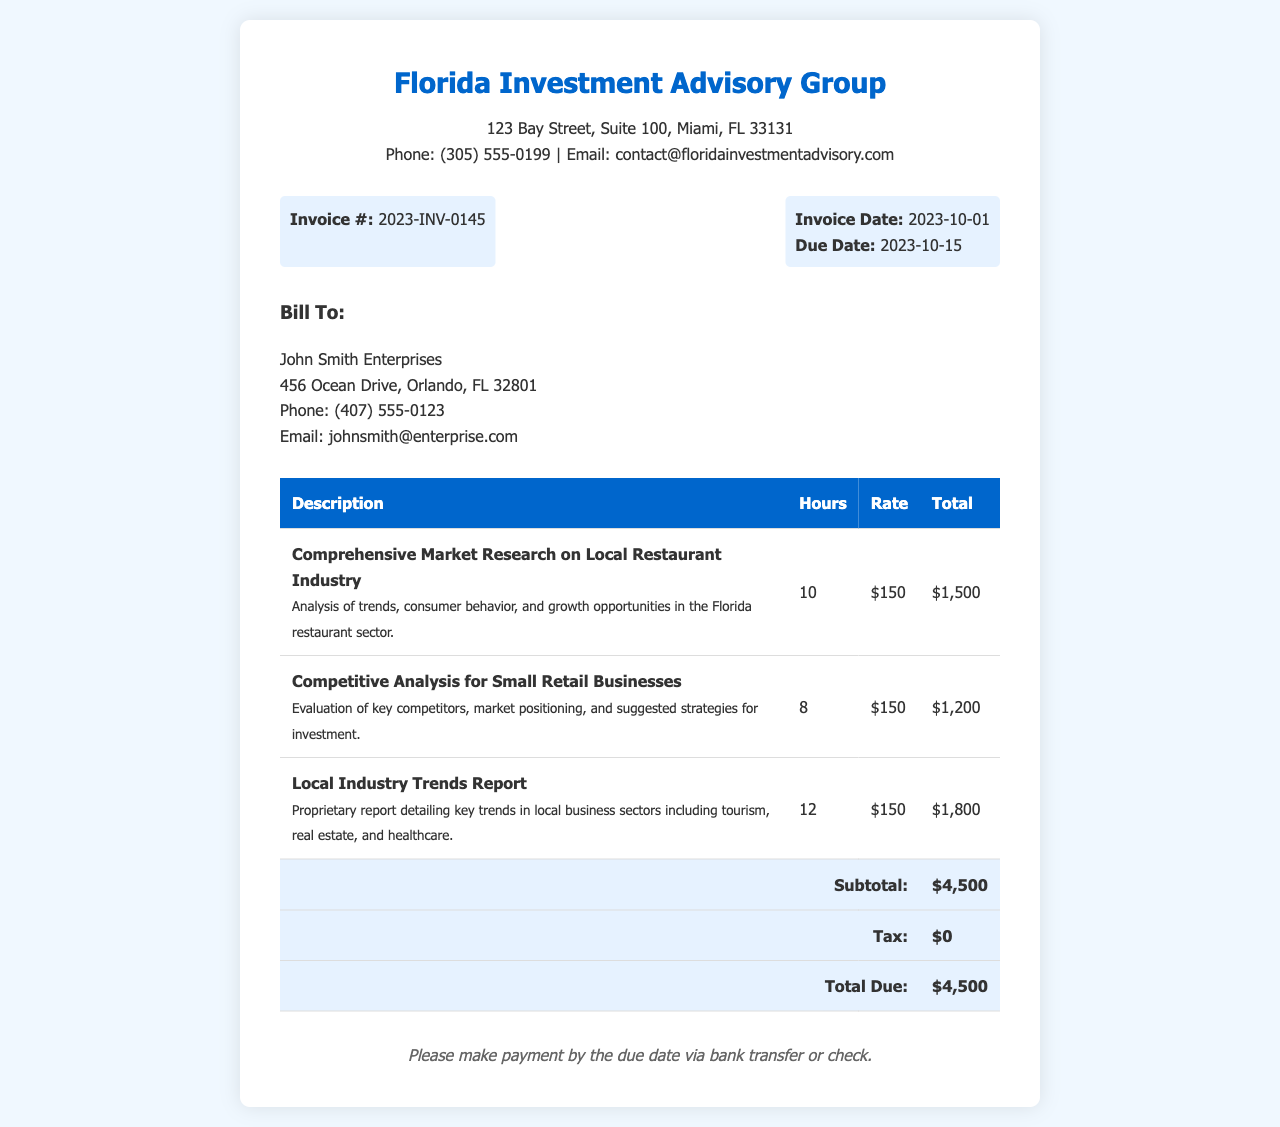what is the invoice number? The invoice number is located in the invoice details section of the document.
Answer: 2023-INV-0145 who is the bill to? The "Bill To" section specifies the entity receiving the invoice.
Answer: John Smith Enterprises what is the total due amount? The total amount due is calculated from the subtotal and tax, which is provided at the end of the invoice.
Answer: $4,500 how many hours were spent on the competitive analysis? The hours for each service are listed in the line items of the invoice.
Answer: 8 when is the due date for payment? The due date is indicated in the invoice details section.
Answer: 2023-10-15 what is the rate charged per hour for the market research services? The hourly rate is specified in the individual service descriptions in the document.
Answer: $150 which industry trends were researched in the report? The description in the local industry trends report details the business sectors analyzed.
Answer: tourism, real estate, and healthcare what is the subtotal before taxes? The subtotal is provided in the invoice table, indicating the total amount before any tax is applied.
Answer: $4,500 how can payment be made? The payment terms at the bottom specify the methods accepted for payment.
Answer: bank transfer or check 